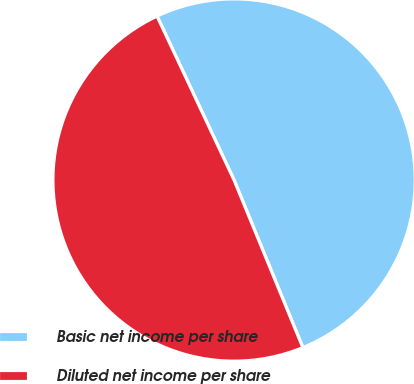<chart> <loc_0><loc_0><loc_500><loc_500><pie_chart><fcel>Basic net income per share<fcel>Diluted net income per share<nl><fcel>50.79%<fcel>49.21%<nl></chart> 